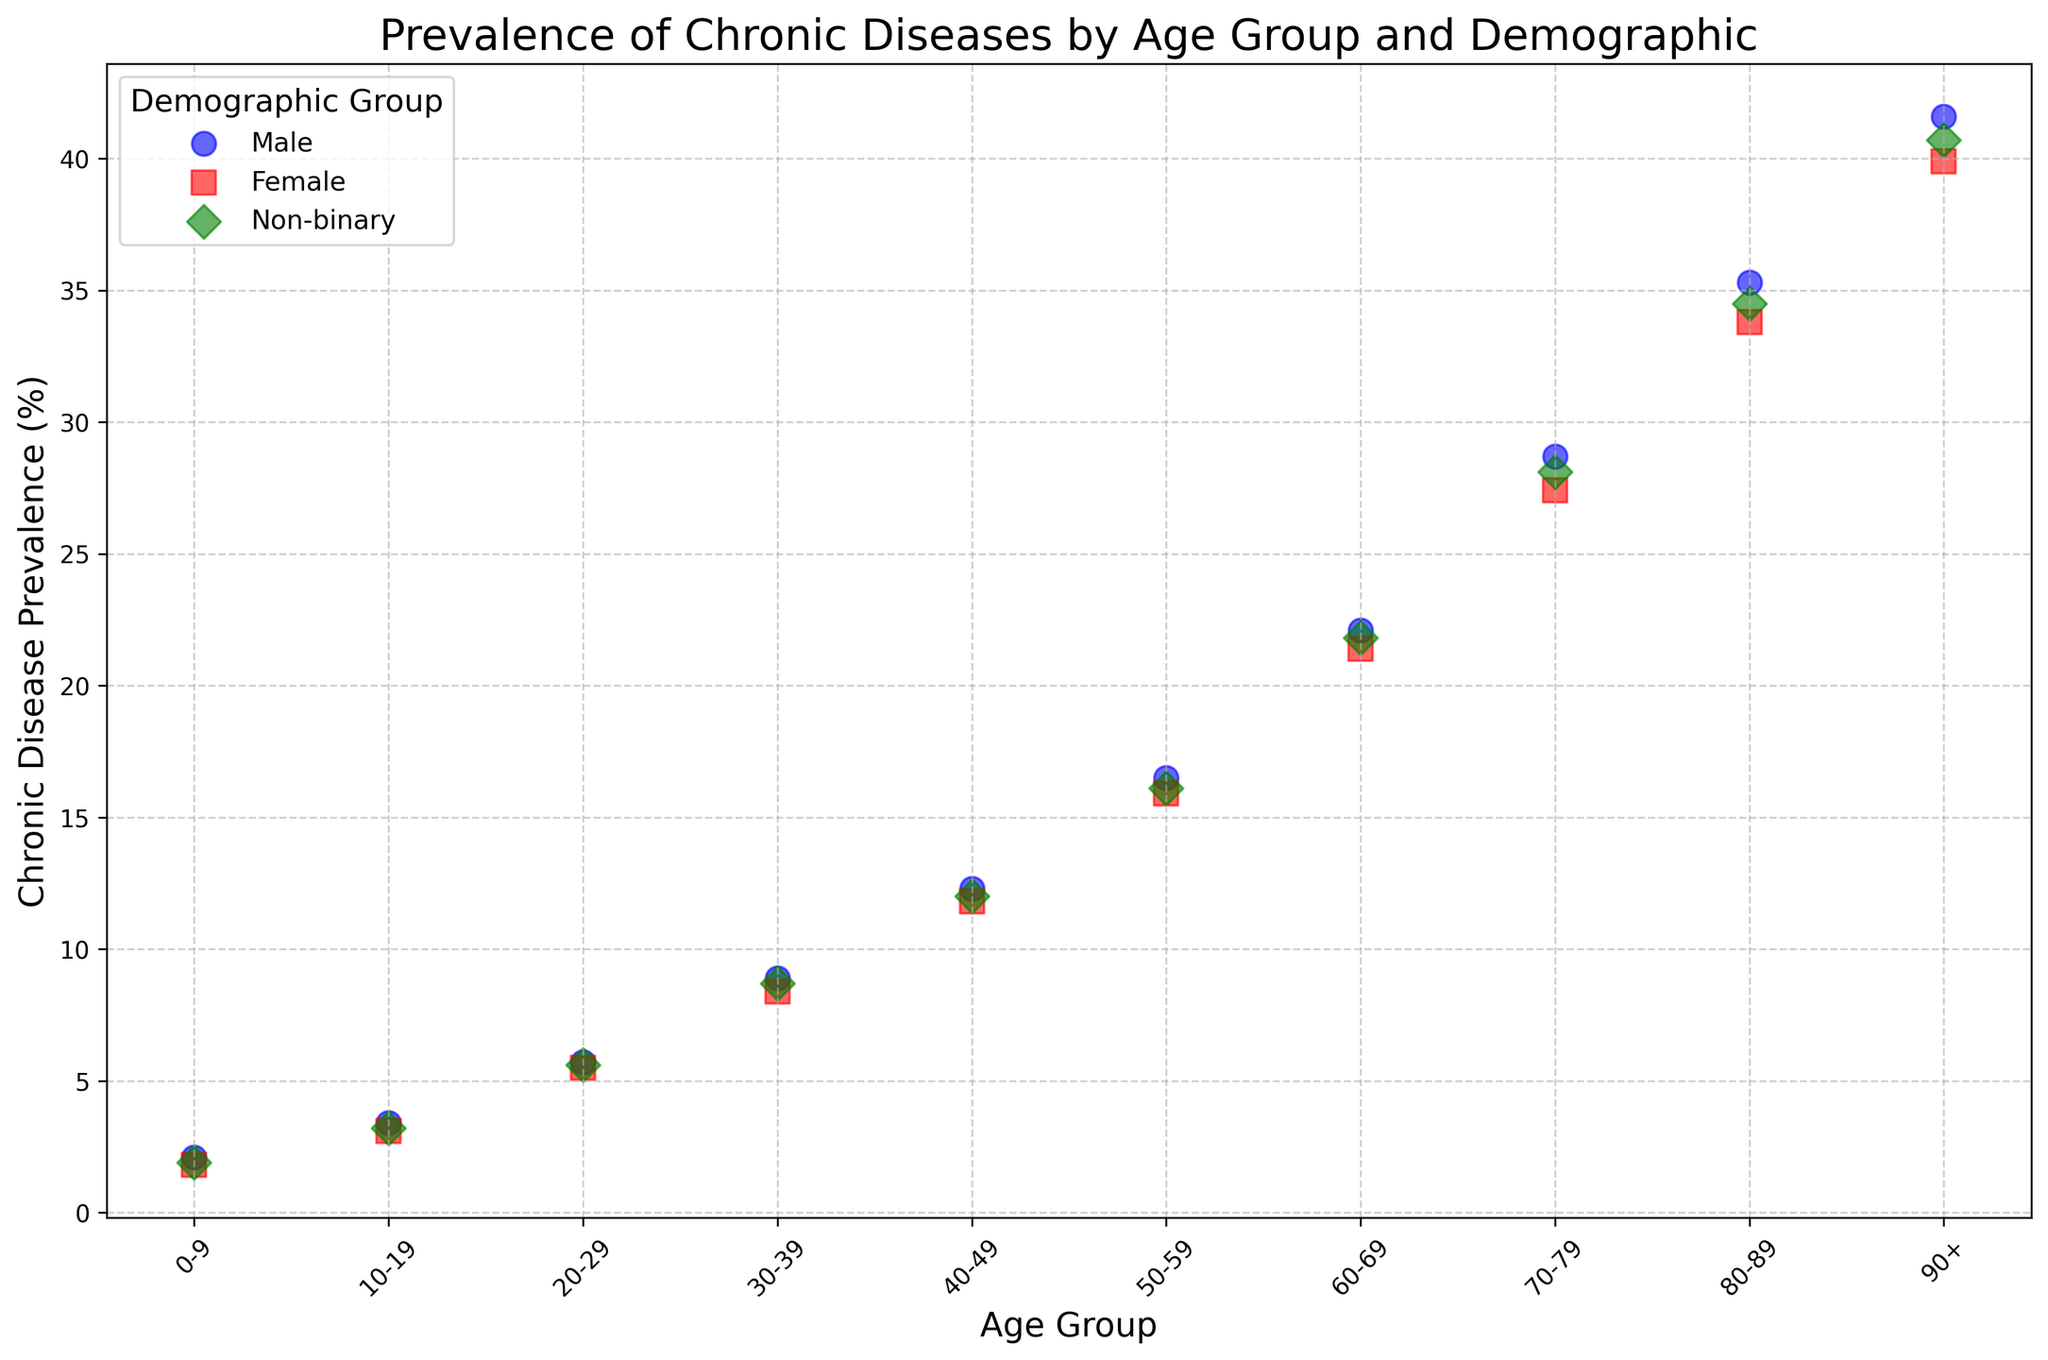What is the general trend in chronic disease prevalence with increasing age? As the age group increases from 0-9 to 90+, the prevalence of chronic diseases generally increases across all demographic groups. This is visible from the scatter plot as the points rise higher along the Y-axis as we move to the right along the X-axis.
Answer: Increasing For the age group 20-29, which demographic group has the highest chronic disease prevalence? In the scatter plot, locate the age group 20-29 on the X-axis and compare the corresponding Y-axis values for each demographic group. The "Male" group has a prevalence of 5.7%, "Female" has 5.5%, and "Non-binary" has 5.6%. Therefore, the "Male" group has the highest prevalence in this age group.
Answer: Male How does the chronic disease prevalence in the 50-59 age group for females compare to that for non-binary individuals? On the scatter plot, find the points corresponding to the age group 50-59. The Y-axis value (prevalence) for females is 15.9%, and for non-binary individuals, it is 16.1%. By comparing these values, it is evident that the non-binary group has a slightly higher prevalence.
Answer: Non-binary has higher prevalence What is the difference in chronic disease prevalence between the youngest and oldest age groups for males? Identify the prevalence values for males in the youngest age group (0-9) and the oldest age group (90+). For age 0-9, the prevalence is 2.1%, and for age 90+, it is 41.6%. The difference is calculated as 41.6% - 2.1% = 39.5%.
Answer: 39.5% Which demographic group shows the smallest increase in chronic disease prevalence when moving from age group 60-69 to 70-79? Locate the points for age groups 60-69 and 70-79 for each demographic group. The prevalence values for males move from 22.1% to 28.7% (increase of 6.6%), for females from 21.4% to 27.4% (increase of 6%), and for non-binary from 21.8% to 28.1% (increase of 6.3%). Therefore, females show the smallest increase.
Answer: Female What is the average chronic disease prevalence for all non-binary individuals? Add the chronic disease prevalence values for all age groups for non-binary individuals and then divide by the number of age groups (10). The values are 1.9%, 3.2%, 5.6%, 8.7%, 12.0%, 16.1%, 21.8%, 28.1%, 34.5%, and 40.7%. Sum them up: 172.6%. Average is 172.6% / 10 = 17.26%.
Answer: 17.26% For the age group 30-39, which demographic group has the lowest chronic disease prevalence? In the scatter plot, locate the age group 30-39 on the X-axis and compare the corresponding Y-axis values for each demographic group. The "Male" group has a prevalence of 8.9%, "Female" has 8.4%, and "Non-binary" has 8.7%. Therefore, the "Female" group has the lowest prevalence in this age group.
Answer: Female How much higher is the chronic disease prevalence for the 80-89 age group compared to the 40-49 age group for females? Find the prevalence values for females in the age groups 40-49 (11.8%) and 80-89 (33.8%). The difference is calculated as 33.8% - 11.8% = 22%.
Answer: 22% Visualize and describe the pattern of chronic disease prevalence for non-binary individuals across all age groups. The scatter plot shows a clear upward trend for non-binary individuals, with prevalence increasing steadily from 1.9% in the 0-9 age group to 40.7% in the 90+ age group. The points form a nearly smooth, ascending path from left to right along the X-axis.
Answer: Upward trend 